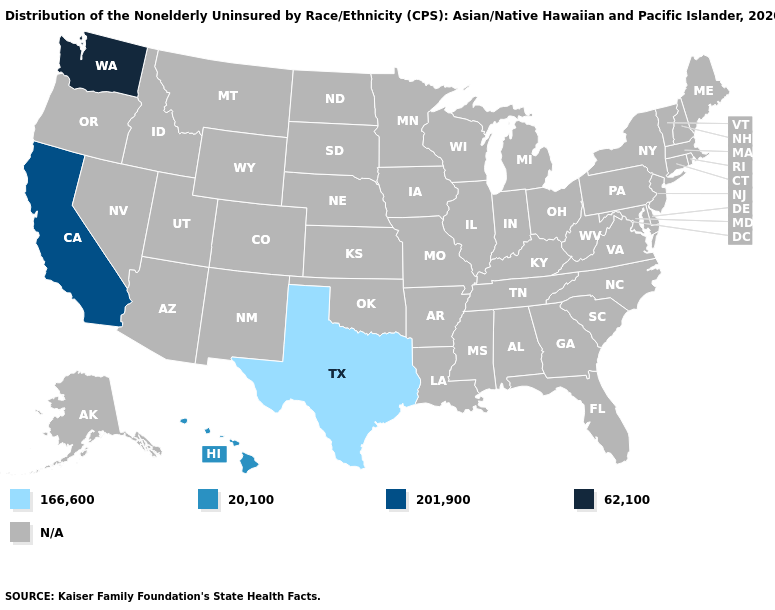Name the states that have a value in the range 201,900?
Quick response, please. California. Name the states that have a value in the range 166,600?
Quick response, please. Texas. Name the states that have a value in the range 201,900?
Write a very short answer. California. Name the states that have a value in the range N/A?
Be succinct. Alabama, Alaska, Arizona, Arkansas, Colorado, Connecticut, Delaware, Florida, Georgia, Idaho, Illinois, Indiana, Iowa, Kansas, Kentucky, Louisiana, Maine, Maryland, Massachusetts, Michigan, Minnesota, Mississippi, Missouri, Montana, Nebraska, Nevada, New Hampshire, New Jersey, New Mexico, New York, North Carolina, North Dakota, Ohio, Oklahoma, Oregon, Pennsylvania, Rhode Island, South Carolina, South Dakota, Tennessee, Utah, Vermont, Virginia, West Virginia, Wisconsin, Wyoming. What is the value of South Carolina?
Keep it brief. N/A. What is the value of Maine?
Write a very short answer. N/A. Name the states that have a value in the range 20,100?
Write a very short answer. Hawaii. Which states have the lowest value in the USA?
Write a very short answer. Texas. What is the value of Louisiana?
Be succinct. N/A. What is the value of Arizona?
Keep it brief. N/A. Name the states that have a value in the range 201,900?
Keep it brief. California. What is the value of North Dakota?
Quick response, please. N/A. 